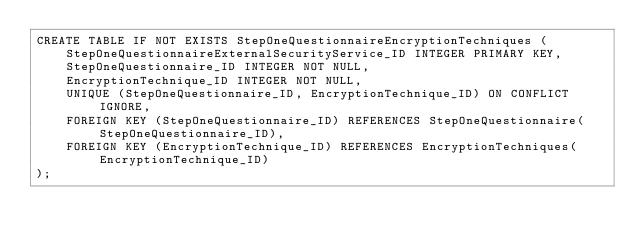<code> <loc_0><loc_0><loc_500><loc_500><_SQL_>CREATE TABLE IF NOT EXISTS StepOneQuestionnaireEncryptionTechniques (
    StepOneQuestionnaireExternalSecurityService_ID INTEGER PRIMARY KEY,
    StepOneQuestionnaire_ID INTEGER NOT NULL,
    EncryptionTechnique_ID INTEGER NOT NULL,
    UNIQUE (StepOneQuestionnaire_ID, EncryptionTechnique_ID) ON CONFLICT IGNORE,
    FOREIGN KEY (StepOneQuestionnaire_ID) REFERENCES StepOneQuestionnaire(StepOneQuestionnaire_ID),
    FOREIGN KEY (EncryptionTechnique_ID) REFERENCES EncryptionTechniques(EncryptionTechnique_ID)
);</code> 